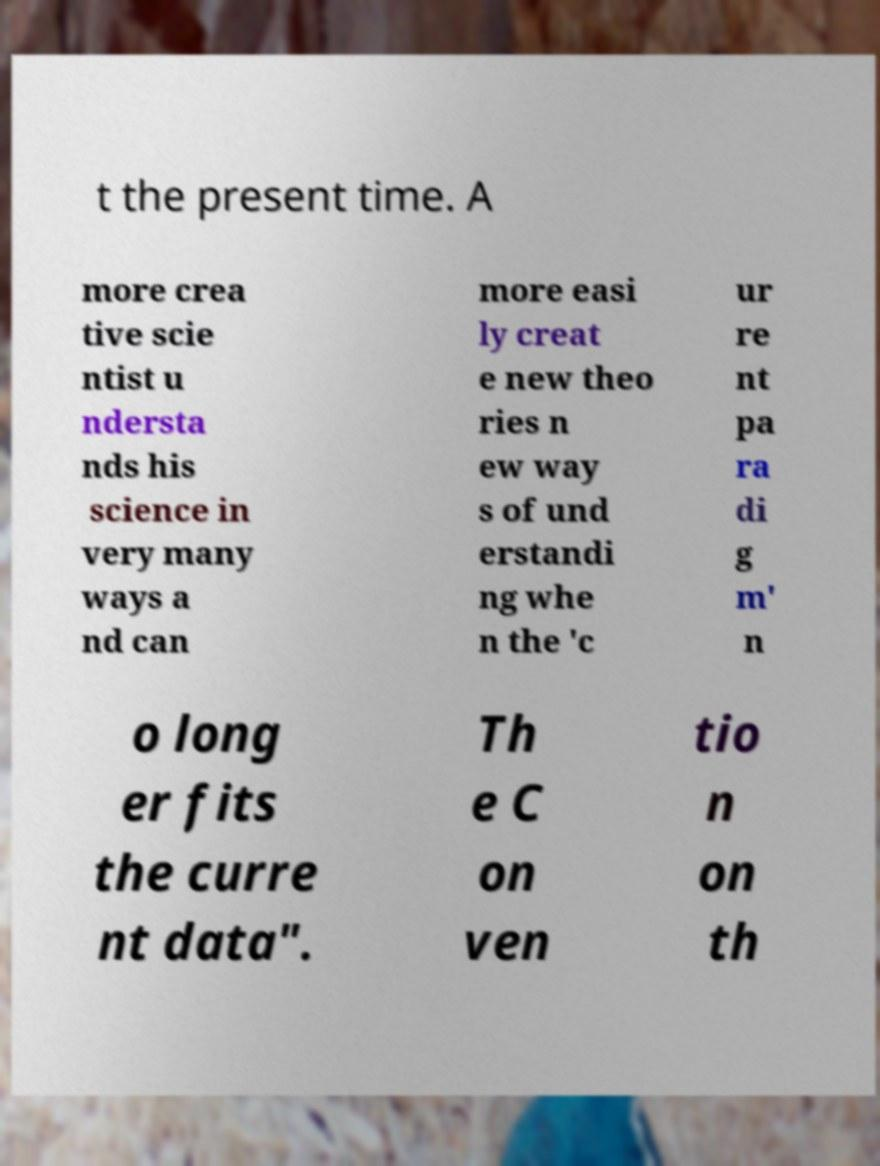Could you assist in decoding the text presented in this image and type it out clearly? t the present time. A more crea tive scie ntist u ndersta nds his science in very many ways a nd can more easi ly creat e new theo ries n ew way s of und erstandi ng whe n the 'c ur re nt pa ra di g m' n o long er fits the curre nt data". Th e C on ven tio n on th 